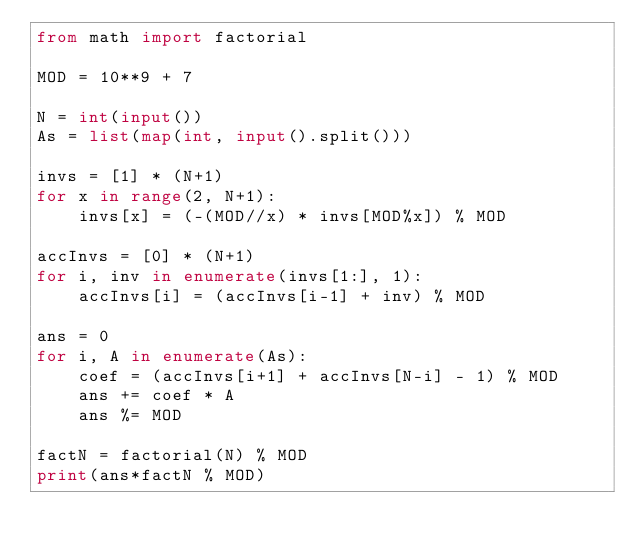<code> <loc_0><loc_0><loc_500><loc_500><_Python_>from math import factorial

MOD = 10**9 + 7

N = int(input())
As = list(map(int, input().split()))

invs = [1] * (N+1)
for x in range(2, N+1):
    invs[x] = (-(MOD//x) * invs[MOD%x]) % MOD

accInvs = [0] * (N+1)
for i, inv in enumerate(invs[1:], 1):
    accInvs[i] = (accInvs[i-1] + inv) % MOD

ans = 0
for i, A in enumerate(As):
    coef = (accInvs[i+1] + accInvs[N-i] - 1) % MOD
    ans += coef * A
    ans %= MOD

factN = factorial(N) % MOD
print(ans*factN % MOD)
</code> 